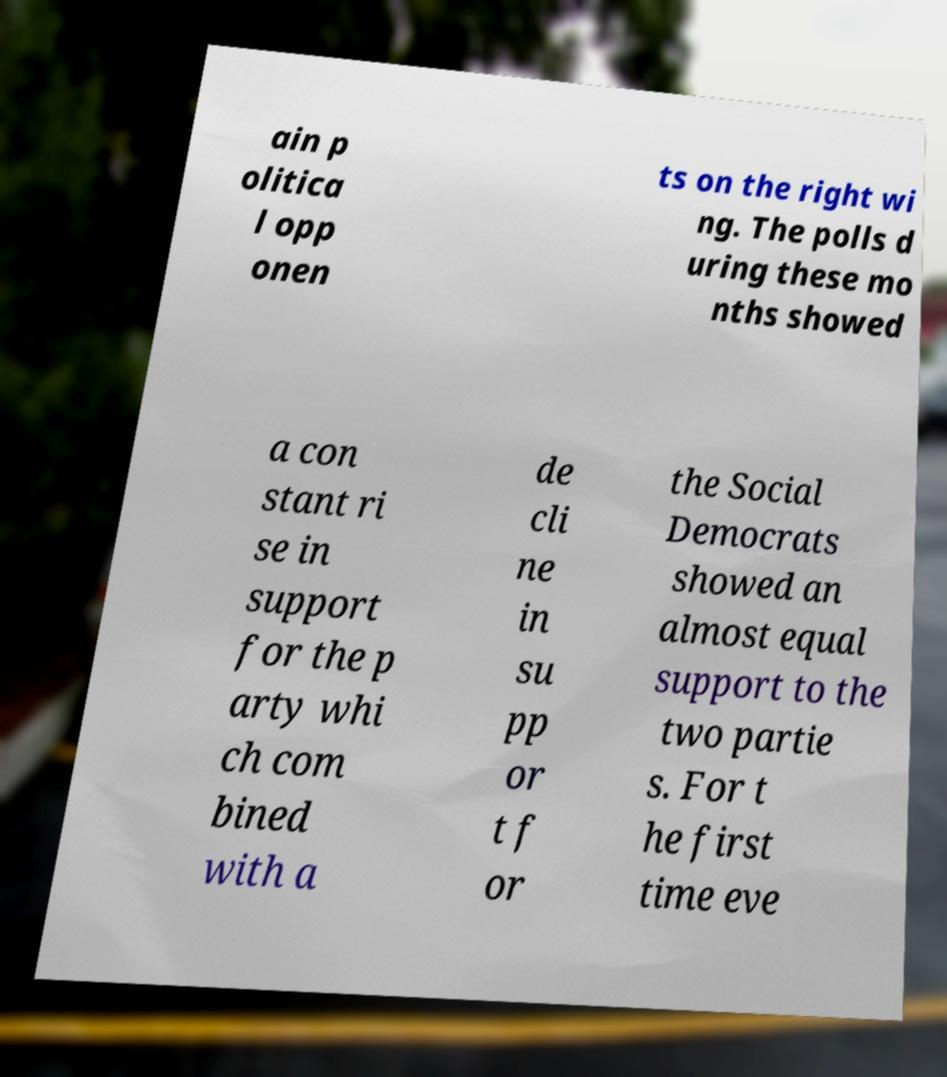Could you assist in decoding the text presented in this image and type it out clearly? ain p olitica l opp onen ts on the right wi ng. The polls d uring these mo nths showed a con stant ri se in support for the p arty whi ch com bined with a de cli ne in su pp or t f or the Social Democrats showed an almost equal support to the two partie s. For t he first time eve 